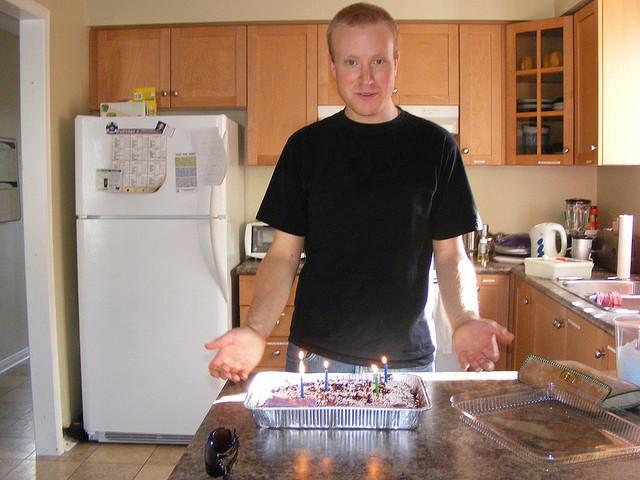Is this a small kitchen?
Give a very brief answer. Yes. Do you see any sunglasses?
Be succinct. Yes. Is the water running in the sink?
Quick response, please. No. What color is his shirt?
Concise answer only. Black. Is the man happy?
Quick response, please. Yes. What brand is the man's shirt?
Be succinct. Hanes. What is in the pan?
Write a very short answer. Cake. 